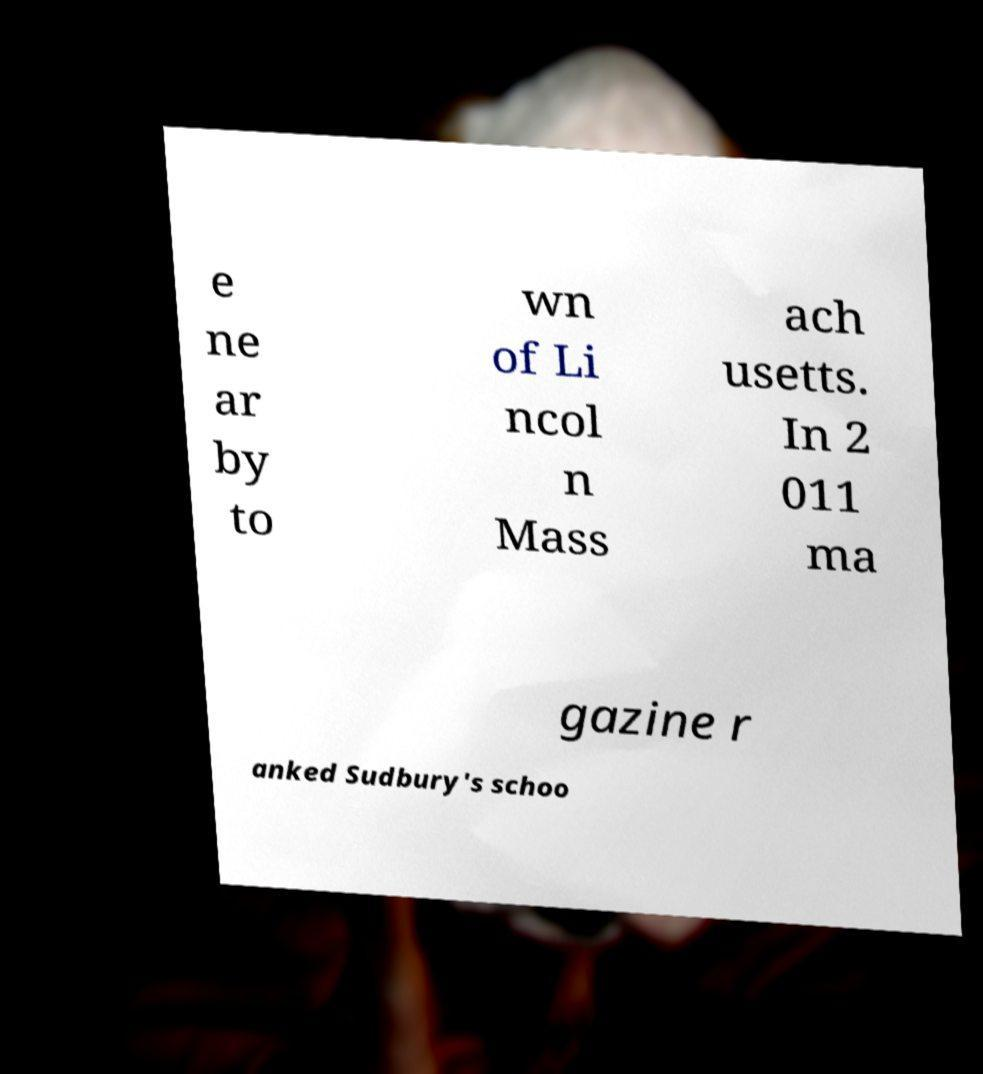What messages or text are displayed in this image? I need them in a readable, typed format. e ne ar by to wn of Li ncol n Mass ach usetts. In 2 011 ma gazine r anked Sudbury's schoo 